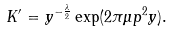<formula> <loc_0><loc_0><loc_500><loc_500>K ^ { \prime } = y ^ { - \frac { \lambda } { 2 } } \exp ( { 2 \pi \mu p ^ { 2 } y } ) .</formula> 